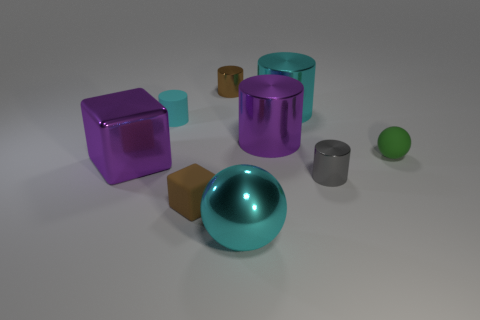Subtract all green spheres. Subtract all red cylinders. How many spheres are left? 1 Subtract all balls. How many objects are left? 7 Add 1 small gray matte things. How many small gray matte things exist? 1 Subtract 2 cyan cylinders. How many objects are left? 7 Subtract all small gray metallic cylinders. Subtract all brown cylinders. How many objects are left? 7 Add 8 large purple metal things. How many large purple metal things are left? 10 